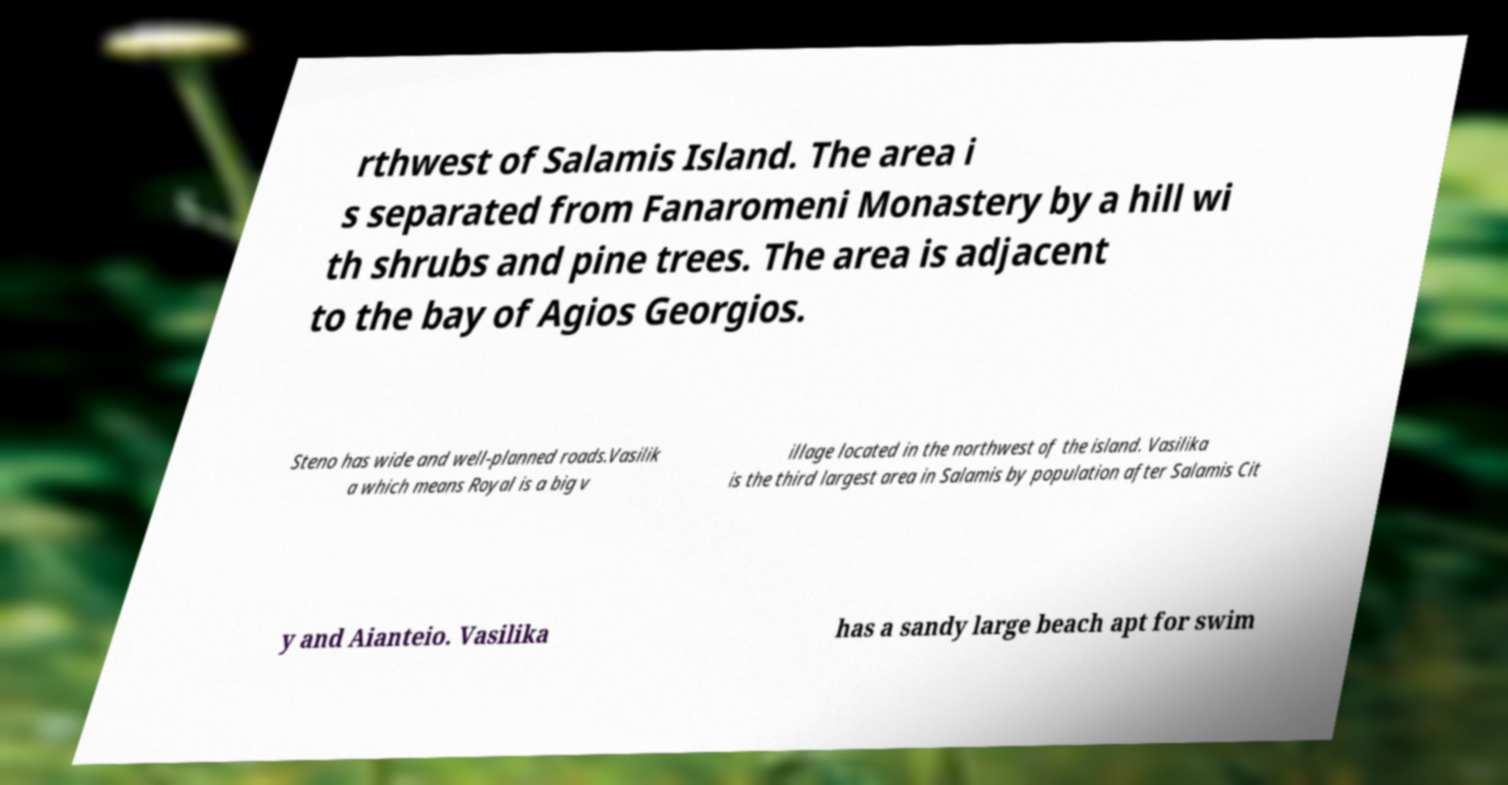I need the written content from this picture converted into text. Can you do that? rthwest of Salamis Island. The area i s separated from Fanaromeni Monastery by a hill wi th shrubs and pine trees. The area is adjacent to the bay of Agios Georgios. Steno has wide and well-planned roads.Vasilik a which means Royal is a big v illage located in the northwest of the island. Vasilika is the third largest area in Salamis by population after Salamis Cit y and Aianteio. Vasilika has a sandy large beach apt for swim 